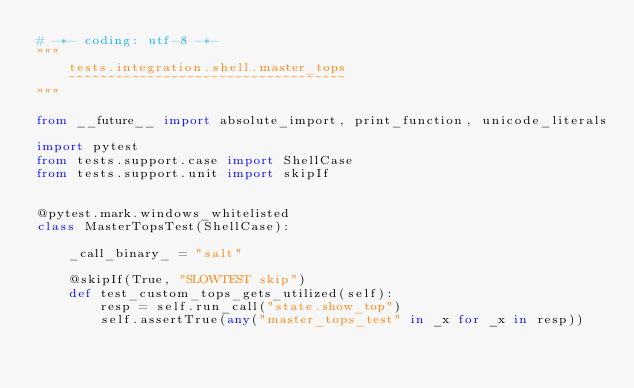Convert code to text. <code><loc_0><loc_0><loc_500><loc_500><_Python_># -*- coding: utf-8 -*-
"""
    tests.integration.shell.master_tops
    ~~~~~~~~~~~~~~~~~~~~~~~~~~~~~~~~~~~
"""

from __future__ import absolute_import, print_function, unicode_literals

import pytest
from tests.support.case import ShellCase
from tests.support.unit import skipIf


@pytest.mark.windows_whitelisted
class MasterTopsTest(ShellCase):

    _call_binary_ = "salt"

    @skipIf(True, "SLOWTEST skip")
    def test_custom_tops_gets_utilized(self):
        resp = self.run_call("state.show_top")
        self.assertTrue(any("master_tops_test" in _x for _x in resp))
</code> 